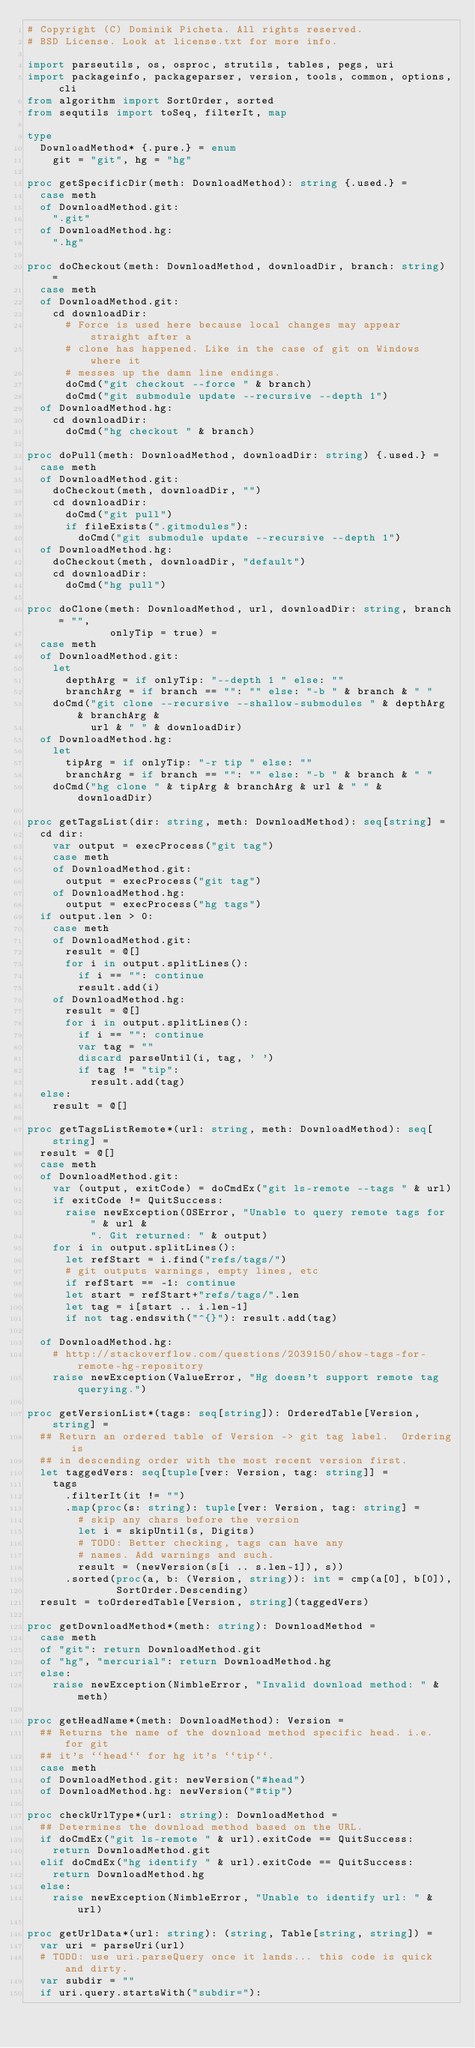<code> <loc_0><loc_0><loc_500><loc_500><_Nim_># Copyright (C) Dominik Picheta. All rights reserved.
# BSD License. Look at license.txt for more info.

import parseutils, os, osproc, strutils, tables, pegs, uri
import packageinfo, packageparser, version, tools, common, options, cli
from algorithm import SortOrder, sorted
from sequtils import toSeq, filterIt, map

type
  DownloadMethod* {.pure.} = enum
    git = "git", hg = "hg"

proc getSpecificDir(meth: DownloadMethod): string {.used.} =
  case meth
  of DownloadMethod.git:
    ".git"
  of DownloadMethod.hg:
    ".hg"

proc doCheckout(meth: DownloadMethod, downloadDir, branch: string) =
  case meth
  of DownloadMethod.git:
    cd downloadDir:
      # Force is used here because local changes may appear straight after a
      # clone has happened. Like in the case of git on Windows where it
      # messes up the damn line endings.
      doCmd("git checkout --force " & branch)
      doCmd("git submodule update --recursive --depth 1")
  of DownloadMethod.hg:
    cd downloadDir:
      doCmd("hg checkout " & branch)

proc doPull(meth: DownloadMethod, downloadDir: string) {.used.} =
  case meth
  of DownloadMethod.git:
    doCheckout(meth, downloadDir, "")
    cd downloadDir:
      doCmd("git pull")
      if fileExists(".gitmodules"):
        doCmd("git submodule update --recursive --depth 1")
  of DownloadMethod.hg:
    doCheckout(meth, downloadDir, "default")
    cd downloadDir:
      doCmd("hg pull")

proc doClone(meth: DownloadMethod, url, downloadDir: string, branch = "",
             onlyTip = true) =
  case meth
  of DownloadMethod.git:
    let
      depthArg = if onlyTip: "--depth 1 " else: ""
      branchArg = if branch == "": "" else: "-b " & branch & " "
    doCmd("git clone --recursive --shallow-submodules " & depthArg & branchArg &
          url & " " & downloadDir)
  of DownloadMethod.hg:
    let
      tipArg = if onlyTip: "-r tip " else: ""
      branchArg = if branch == "": "" else: "-b " & branch & " "
    doCmd("hg clone " & tipArg & branchArg & url & " " & downloadDir)

proc getTagsList(dir: string, meth: DownloadMethod): seq[string] =
  cd dir:
    var output = execProcess("git tag")
    case meth
    of DownloadMethod.git:
      output = execProcess("git tag")
    of DownloadMethod.hg:
      output = execProcess("hg tags")
  if output.len > 0:
    case meth
    of DownloadMethod.git:
      result = @[]
      for i in output.splitLines():
        if i == "": continue
        result.add(i)
    of DownloadMethod.hg:
      result = @[]
      for i in output.splitLines():
        if i == "": continue
        var tag = ""
        discard parseUntil(i, tag, ' ')
        if tag != "tip":
          result.add(tag)
  else:
    result = @[]

proc getTagsListRemote*(url: string, meth: DownloadMethod): seq[string] =
  result = @[]
  case meth
  of DownloadMethod.git:
    var (output, exitCode) = doCmdEx("git ls-remote --tags " & url)
    if exitCode != QuitSuccess:
      raise newException(OSError, "Unable to query remote tags for " & url &
          ". Git returned: " & output)
    for i in output.splitLines():
      let refStart = i.find("refs/tags/")
      # git outputs warnings, empty lines, etc
      if refStart == -1: continue
      let start = refStart+"refs/tags/".len
      let tag = i[start .. i.len-1]
      if not tag.endswith("^{}"): result.add(tag)

  of DownloadMethod.hg:
    # http://stackoverflow.com/questions/2039150/show-tags-for-remote-hg-repository
    raise newException(ValueError, "Hg doesn't support remote tag querying.")

proc getVersionList*(tags: seq[string]): OrderedTable[Version, string] =
  ## Return an ordered table of Version -> git tag label.  Ordering is
  ## in descending order with the most recent version first.
  let taggedVers: seq[tuple[ver: Version, tag: string]] =
    tags
      .filterIt(it != "")
      .map(proc(s: string): tuple[ver: Version, tag: string] =
        # skip any chars before the version
        let i = skipUntil(s, Digits)
        # TODO: Better checking, tags can have any
        # names. Add warnings and such.
        result = (newVersion(s[i .. s.len-1]), s))
      .sorted(proc(a, b: (Version, string)): int = cmp(a[0], b[0]),
              SortOrder.Descending)
  result = toOrderedTable[Version, string](taggedVers)

proc getDownloadMethod*(meth: string): DownloadMethod =
  case meth
  of "git": return DownloadMethod.git
  of "hg", "mercurial": return DownloadMethod.hg
  else:
    raise newException(NimbleError, "Invalid download method: " & meth)

proc getHeadName*(meth: DownloadMethod): Version =
  ## Returns the name of the download method specific head. i.e. for git
  ## it's ``head`` for hg it's ``tip``.
  case meth
  of DownloadMethod.git: newVersion("#head")
  of DownloadMethod.hg: newVersion("#tip")

proc checkUrlType*(url: string): DownloadMethod =
  ## Determines the download method based on the URL.
  if doCmdEx("git ls-remote " & url).exitCode == QuitSuccess:
    return DownloadMethod.git
  elif doCmdEx("hg identify " & url).exitCode == QuitSuccess:
    return DownloadMethod.hg
  else:
    raise newException(NimbleError, "Unable to identify url: " & url)

proc getUrlData*(url: string): (string, Table[string, string]) =
  var uri = parseUri(url)
  # TODO: use uri.parseQuery once it lands... this code is quick and dirty.
  var subdir = ""
  if uri.query.startsWith("subdir="):</code> 